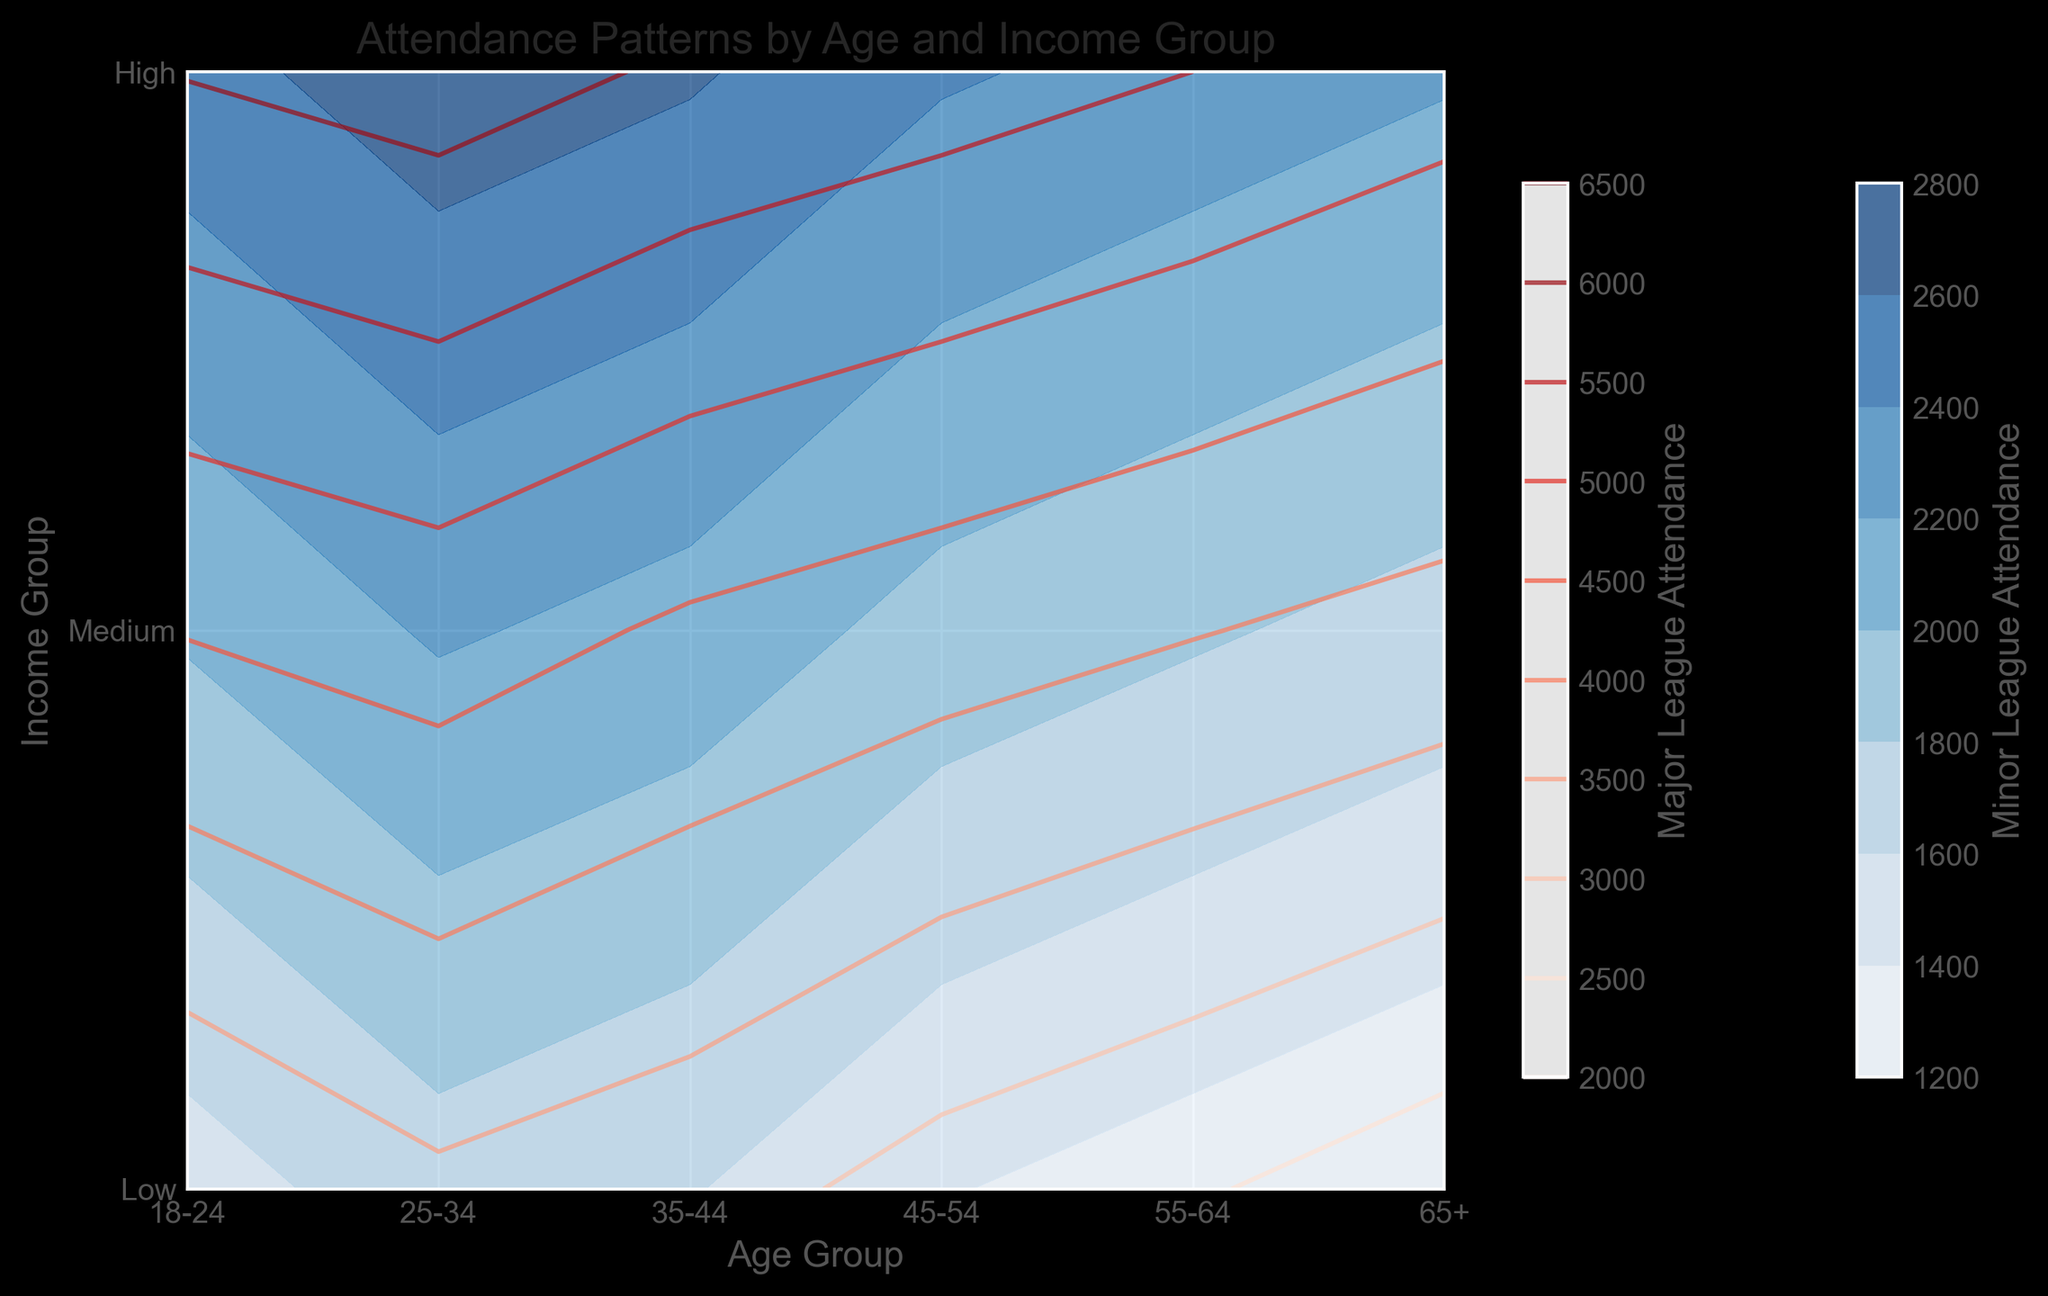Which age group has the highest minor league attendance among the high-income group? Look at the contour for minor league attendance in the high-income group and identify the highest value along the age axis. The deepest color in the high section corresponds to the highest attendance.
Answer: 25-34 How does minor league attendance for the 18-24 low-income group compare to the major league attendance for the same group? Compare the height and color intensity of the contours for both minor and major league attendance in the 18-24 low-income group. The major league contour will usually be brighter or have a higher peak if attendance is higher.
Answer: Major league is higher What is the average major league attendance across all age groups for the medium-income group? Identify the contour values or heights for medium income across all age groups in major league and compute the average of those values. This involves summing up the attendance figures and dividing by the number of groups.
Answer: 4466.7 Which income group shows the lowest variation in minor league attendance across different age groups? Assess the uniformity of the contour lines for minor league attendance across different age groups within each income level. The group with lines closest to one another and possessing less gradient variation has the lowest variability.
Answer: High Is the major league attendance for the 55-64 medium-income group higher or lower than the minor league attendance for the 35-44 high-income group? Compare the contour heights/colors for 55-64 medium-income in major league directly against 35-44 high-income in minor league. They'll be higher where the contour is steeper or color deeper.
Answer: Higher Which age group and income group combination has the maximum major league attendance? Search for the highest contour peak or the most intense color shade in the major league attendance plot. High income typically shows the highest values, so checking within this range helps identify the answer.
Answer: 25-34 High How does minor league attendance for the 65+ high-income group compare to major league attendance for the same group? Examine the contour levels for both leagues under the 65+ age group with high income, noting the difference in heights and color intensities.
Answer: Major league is higher What is the difference between major league and minor league attendance for the 45-54 low-income group? Locate contours for both leagues under 45-54 low income and subtract the minor league attendance value from the major league value to get the difference.
Answer: 1400 